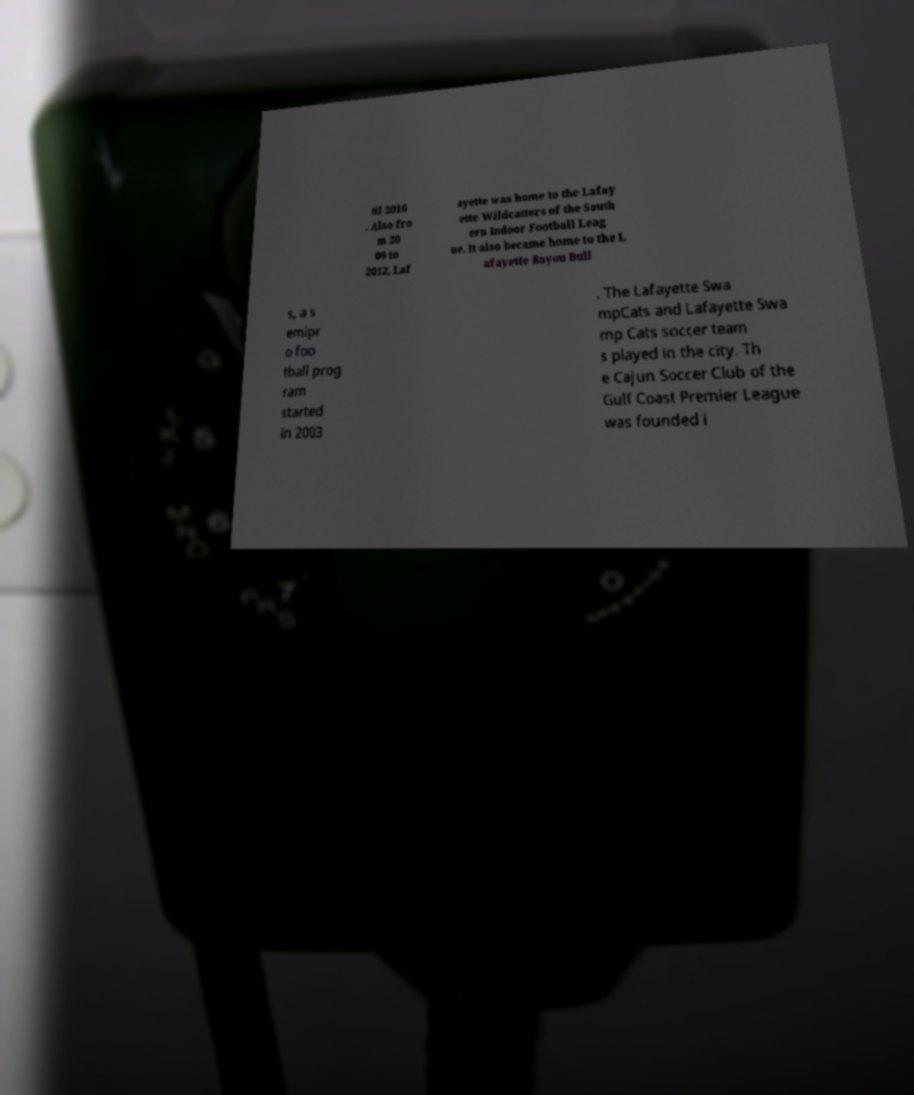For documentation purposes, I need the text within this image transcribed. Could you provide that? til 2016 . Also fro m 20 09 to 2012, Laf ayette was home to the Lafay ette Wildcatters of the South ern Indoor Football Leag ue. It also became home to the L afayette Bayou Bull s, a s emipr o foo tball prog ram started in 2003 . The Lafayette Swa mpCats and Lafayette Swa mp Cats soccer team s played in the city. Th e Cajun Soccer Club of the Gulf Coast Premier League was founded i 